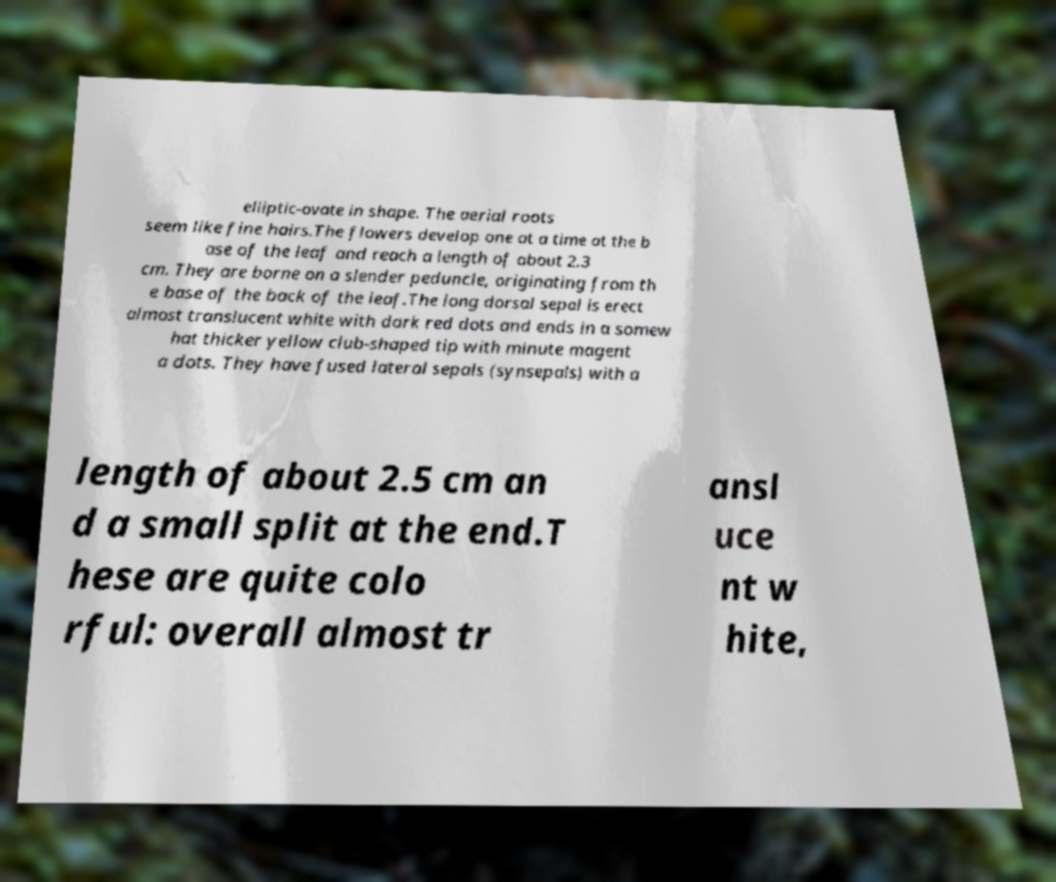Please identify and transcribe the text found in this image. elliptic-ovate in shape. The aerial roots seem like fine hairs.The flowers develop one at a time at the b ase of the leaf and reach a length of about 2.3 cm. They are borne on a slender peduncle, originating from th e base of the back of the leaf.The long dorsal sepal is erect almost translucent white with dark red dots and ends in a somew hat thicker yellow club-shaped tip with minute magent a dots. They have fused lateral sepals (synsepals) with a length of about 2.5 cm an d a small split at the end.T hese are quite colo rful: overall almost tr ansl uce nt w hite, 